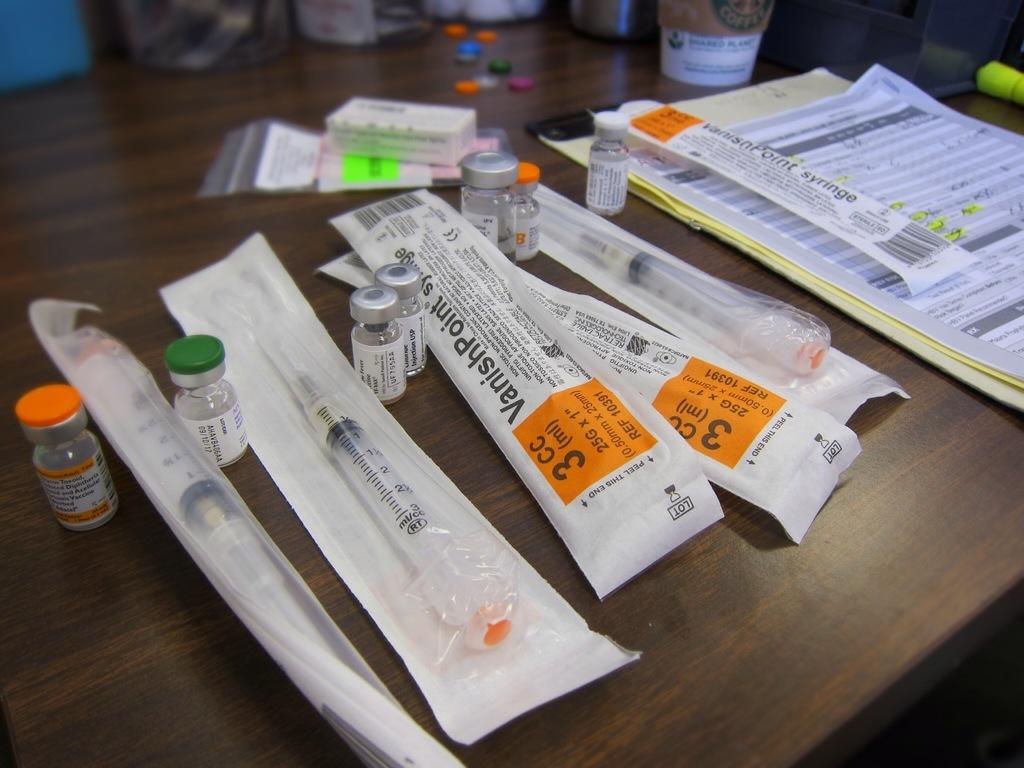<image>
Present a compact description of the photo's key features. the number 3 is on the paper item 